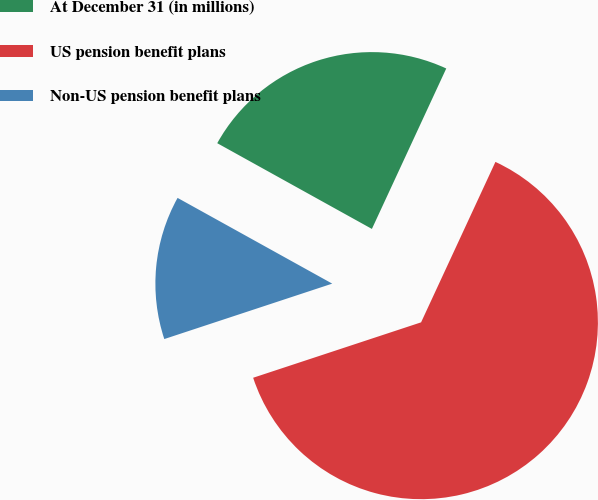Convert chart to OTSL. <chart><loc_0><loc_0><loc_500><loc_500><pie_chart><fcel>At December 31 (in millions)<fcel>US pension benefit plans<fcel>Non-US pension benefit plans<nl><fcel>23.85%<fcel>63.02%<fcel>13.13%<nl></chart> 